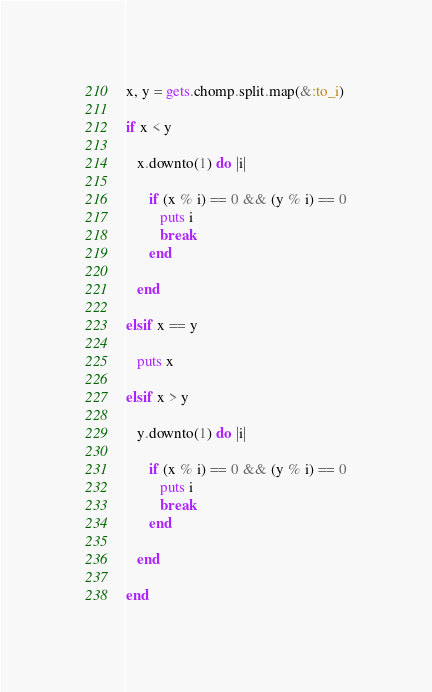<code> <loc_0><loc_0><loc_500><loc_500><_Ruby_>x, y = gets.chomp.split.map(&:to_i)

if x < y

   x.downto(1) do |i|

      if (x % i) == 0 && (y % i) == 0
         puts i
         break
      end

   end

elsif x == y

   puts x

elsif x > y

   y.downto(1) do |i|

      if (x % i) == 0 && (y % i) == 0
         puts i
         break
      end

   end

end</code> 